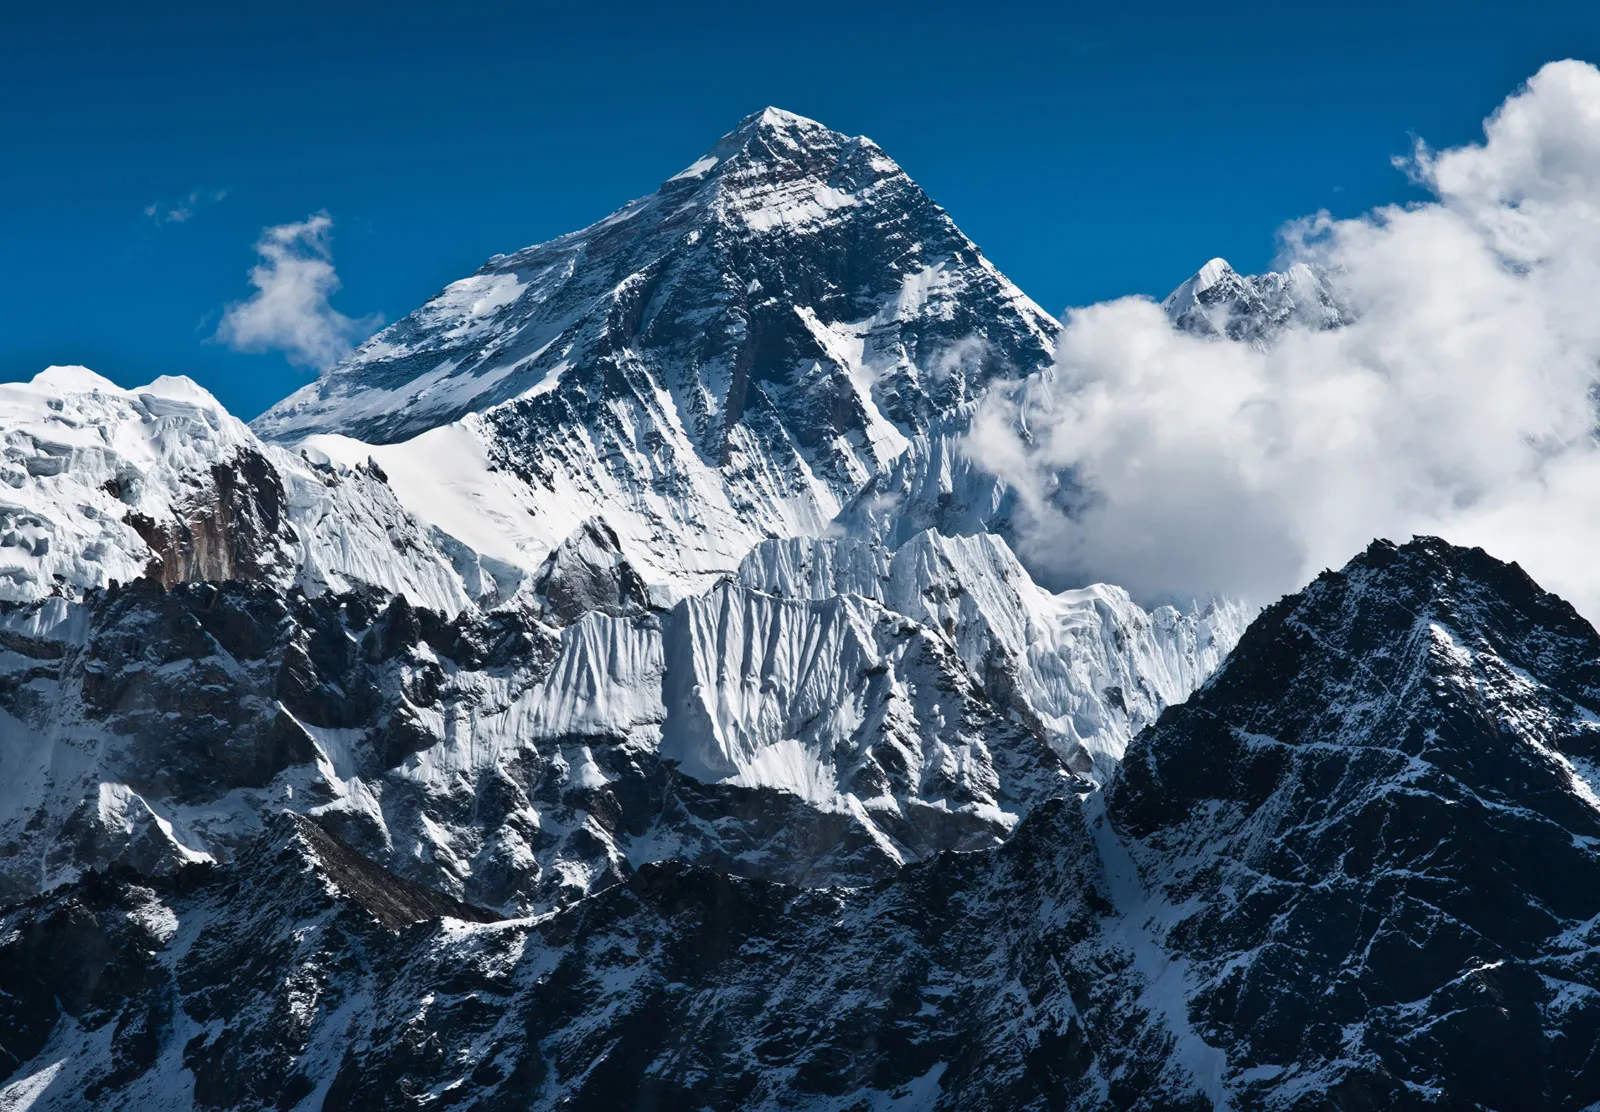Explain the visual content of the image in great detail. The image presents a stunning, panoramic view of Mount Everest, the tallest mountain in the world. Dominating the center of the frame, Everest's mighty peak is capped with layers of sparkling white snow and thick ice, showcasing nature's raw power and beauty. The foreground is filled with a dramatic contrast of rocky terrains and jagged snow-clad ridges, enhancing the rugged and imposing feel of the landscape. The surrounding sky is a deep, clear blue, interrupted only by a few stray, cotton-like clouds floating gently around the upper reaches of the mountain, accentuating its sheer height and grandeur. In the distance, the majestic peaks of the Himalayan range stretch out as far as the eye can see, each varying in size but uniform in their snow-covered surfaces, contributing to a breathtaking and serene visual harmony. The absence of human presence or any man-made objects underscores the remote and untouched character of this natural masterpiece, reinforcing its status as one of the Earth's most isolated and awe-inspiring landmarks. 